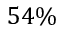Convert formula to latex. <formula><loc_0><loc_0><loc_500><loc_500>5 4 \%</formula> 